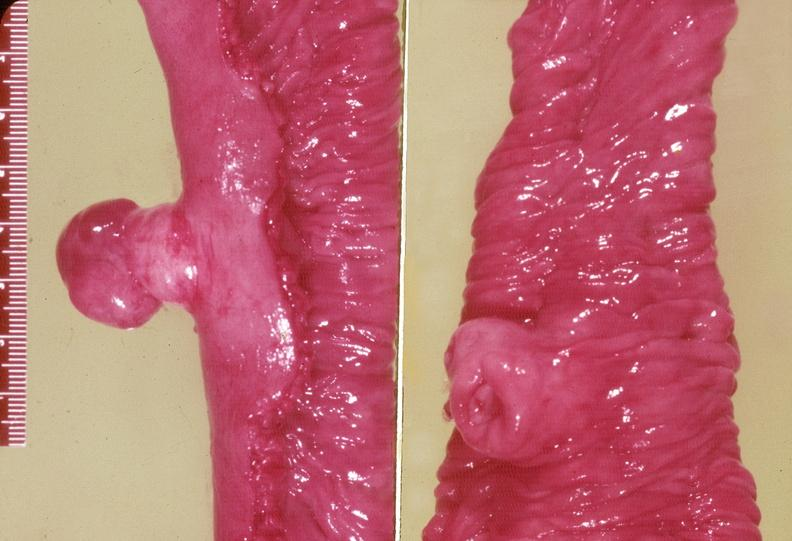s surface present?
Answer the question using a single word or phrase. No 